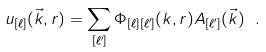<formula> <loc_0><loc_0><loc_500><loc_500>u _ { [ \ell ] } ( \vec { k } , r ) = \sum _ { [ \ell ^ { \prime } ] } \Phi _ { [ \ell ] [ \ell ^ { \prime } ] } ( k , r ) A _ { [ \ell ^ { \prime } ] } ( \vec { k } ) \ .</formula> 